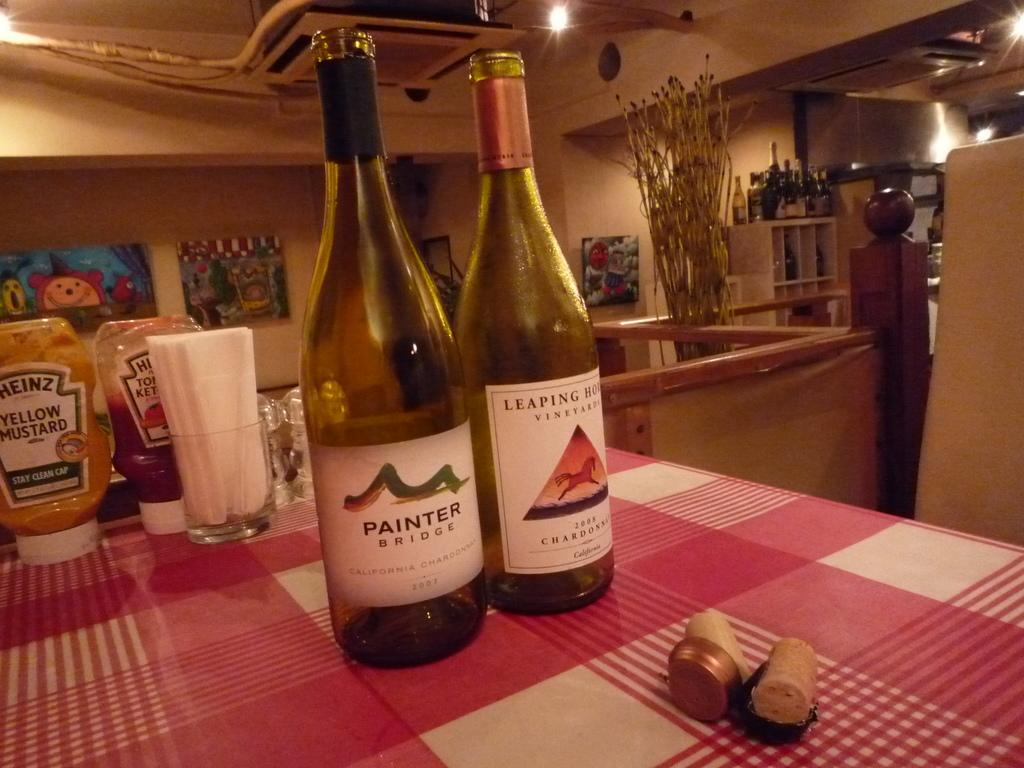<image>
Summarize the visual content of the image. A bottle of Painter Bridge wine from California from 20007. 